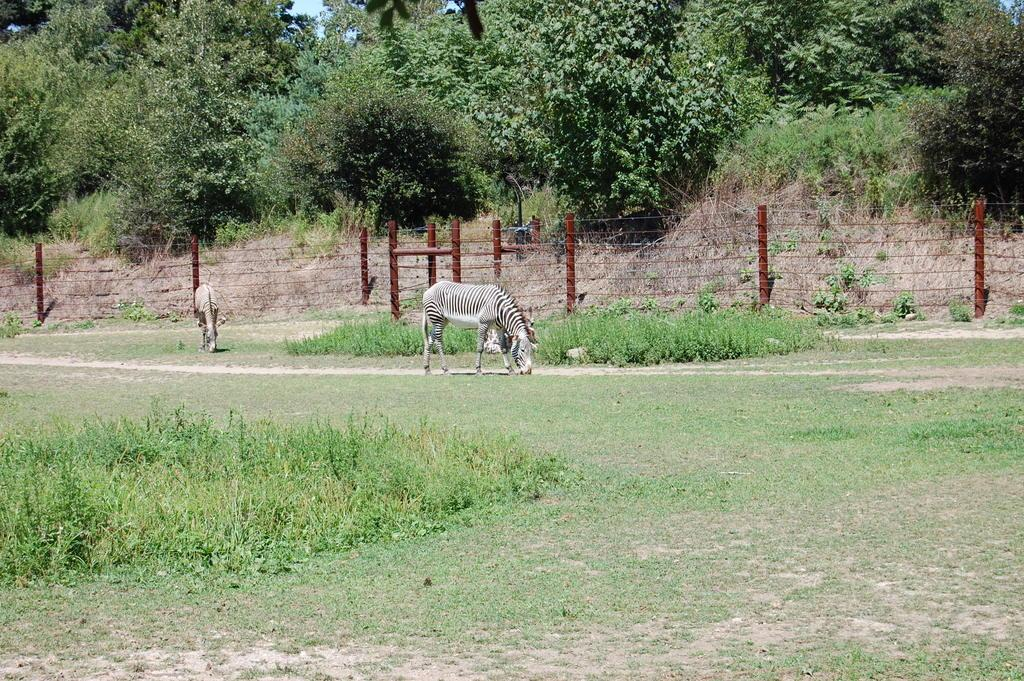What animals can be seen in the image? There are zebras in the image. What type of vegetation is present in the image? There is grass and plants in the image. What structure can be seen in the image? There is a fence in the image. What can be seen in the background of the image? There are trees and the sky visible in the background of the image. What type of flower is being waved by the zebra in the image? There are no flowers or waving actions depicted in the image; it features zebras, grass, plants, a fence, trees, and the sky. 